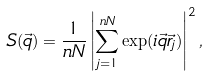<formula> <loc_0><loc_0><loc_500><loc_500>S ( \vec { q } ) = \frac { 1 } { n N } \left | \sum _ { j = 1 } ^ { n N } \exp ( i \vec { q } \vec { r } _ { j } ) \right | ^ { 2 } ,</formula> 